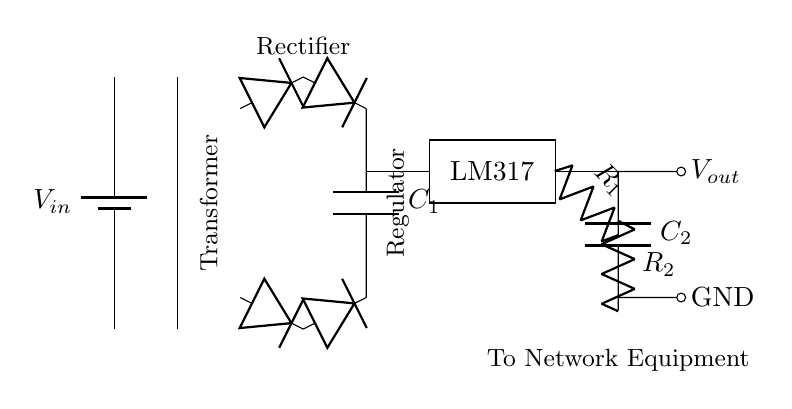What does the circuit provide to network equipment? The output from the circuit is connected directly to network equipment, which it powers, demonstrating that the circuit provides a stable voltage supply.
Answer: Voltage What component is used for voltage regulation in this circuit? The circuit uses the LM317 as a voltage regulator, which is a common component known for its ability to supply a stable output voltage to devices.
Answer: LM317 What is the purpose of the smoothing capacitor? The smoothing capacitor (C1) acts to reduce voltage ripple after rectification, ensuring a more stable DC voltage is delivered to the regulator, thus improving performance.
Answer: Reduce ripple How many diodes are in the rectifier bridge? There are four diodes in the bridge rectifier arrangement, which work together to convert AC voltage to DC voltage.
Answer: Four What is the function of the resistors R1 and R2 in this circuit? Resistors R1 and R2 are used to set and adjust the output voltage from the LM317 regulator, allowing for different voltage levels to be achieved based on their values.
Answer: Voltage adjustment What is the input voltage source in this circuit? The diagram indicates that the input voltage source is represented as Vin, which suggests a designated voltage value must be applied prior to regulation.
Answer: Vin What type of converter is used before voltage regulation? The transformer is the first component that steps down the voltage from AC supply, which is essential as it is the initial stage in preparing the voltage for rectification and regulation.
Answer: Transformer 